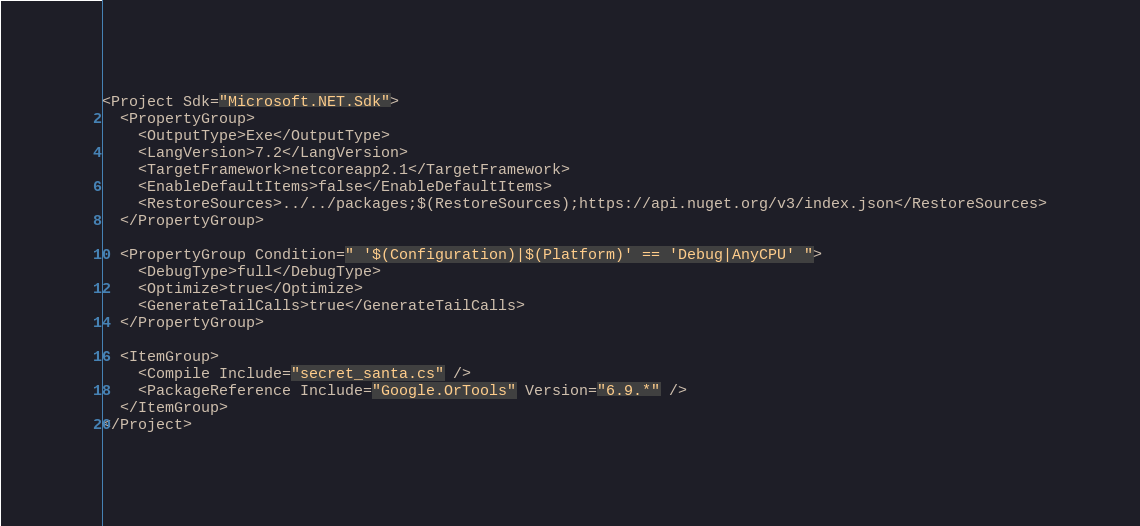Convert code to text. <code><loc_0><loc_0><loc_500><loc_500><_XML_><Project Sdk="Microsoft.NET.Sdk">
  <PropertyGroup>
    <OutputType>Exe</OutputType>
    <LangVersion>7.2</LangVersion>
    <TargetFramework>netcoreapp2.1</TargetFramework>
    <EnableDefaultItems>false</EnableDefaultItems>
    <RestoreSources>../../packages;$(RestoreSources);https://api.nuget.org/v3/index.json</RestoreSources>
  </PropertyGroup>

  <PropertyGroup Condition=" '$(Configuration)|$(Platform)' == 'Debug|AnyCPU' ">
    <DebugType>full</DebugType>
    <Optimize>true</Optimize>
    <GenerateTailCalls>true</GenerateTailCalls>
  </PropertyGroup>

  <ItemGroup>
    <Compile Include="secret_santa.cs" />
    <PackageReference Include="Google.OrTools" Version="6.9.*" />
  </ItemGroup>
</Project>
</code> 